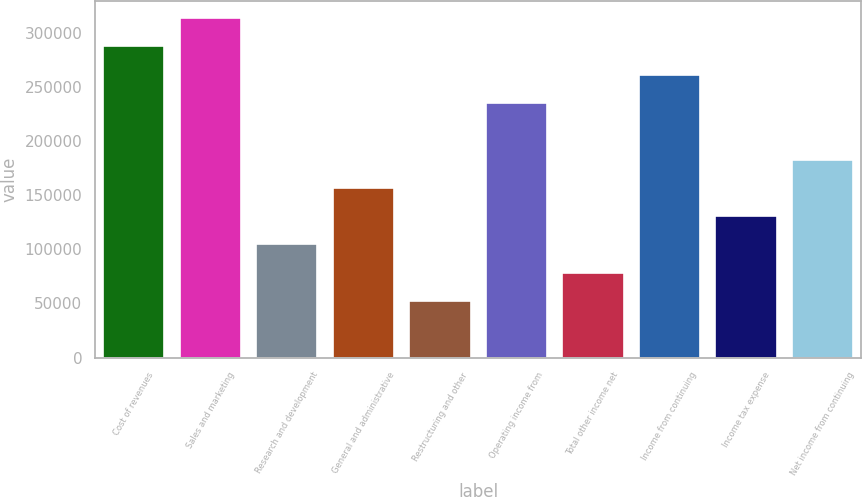<chart> <loc_0><loc_0><loc_500><loc_500><bar_chart><fcel>Cost of revenues<fcel>Sales and marketing<fcel>Research and development<fcel>General and administrative<fcel>Restructuring and other<fcel>Operating income from<fcel>Total other income net<fcel>Income from continuing<fcel>Income tax expense<fcel>Net income from continuing<nl><fcel>287363<fcel>313487<fcel>104496<fcel>156743<fcel>52247.8<fcel>235115<fcel>78371.7<fcel>261239<fcel>130620<fcel>182867<nl></chart> 